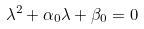<formula> <loc_0><loc_0><loc_500><loc_500>\lambda ^ { 2 } + \alpha _ { 0 } \lambda + \beta _ { 0 } = 0</formula> 